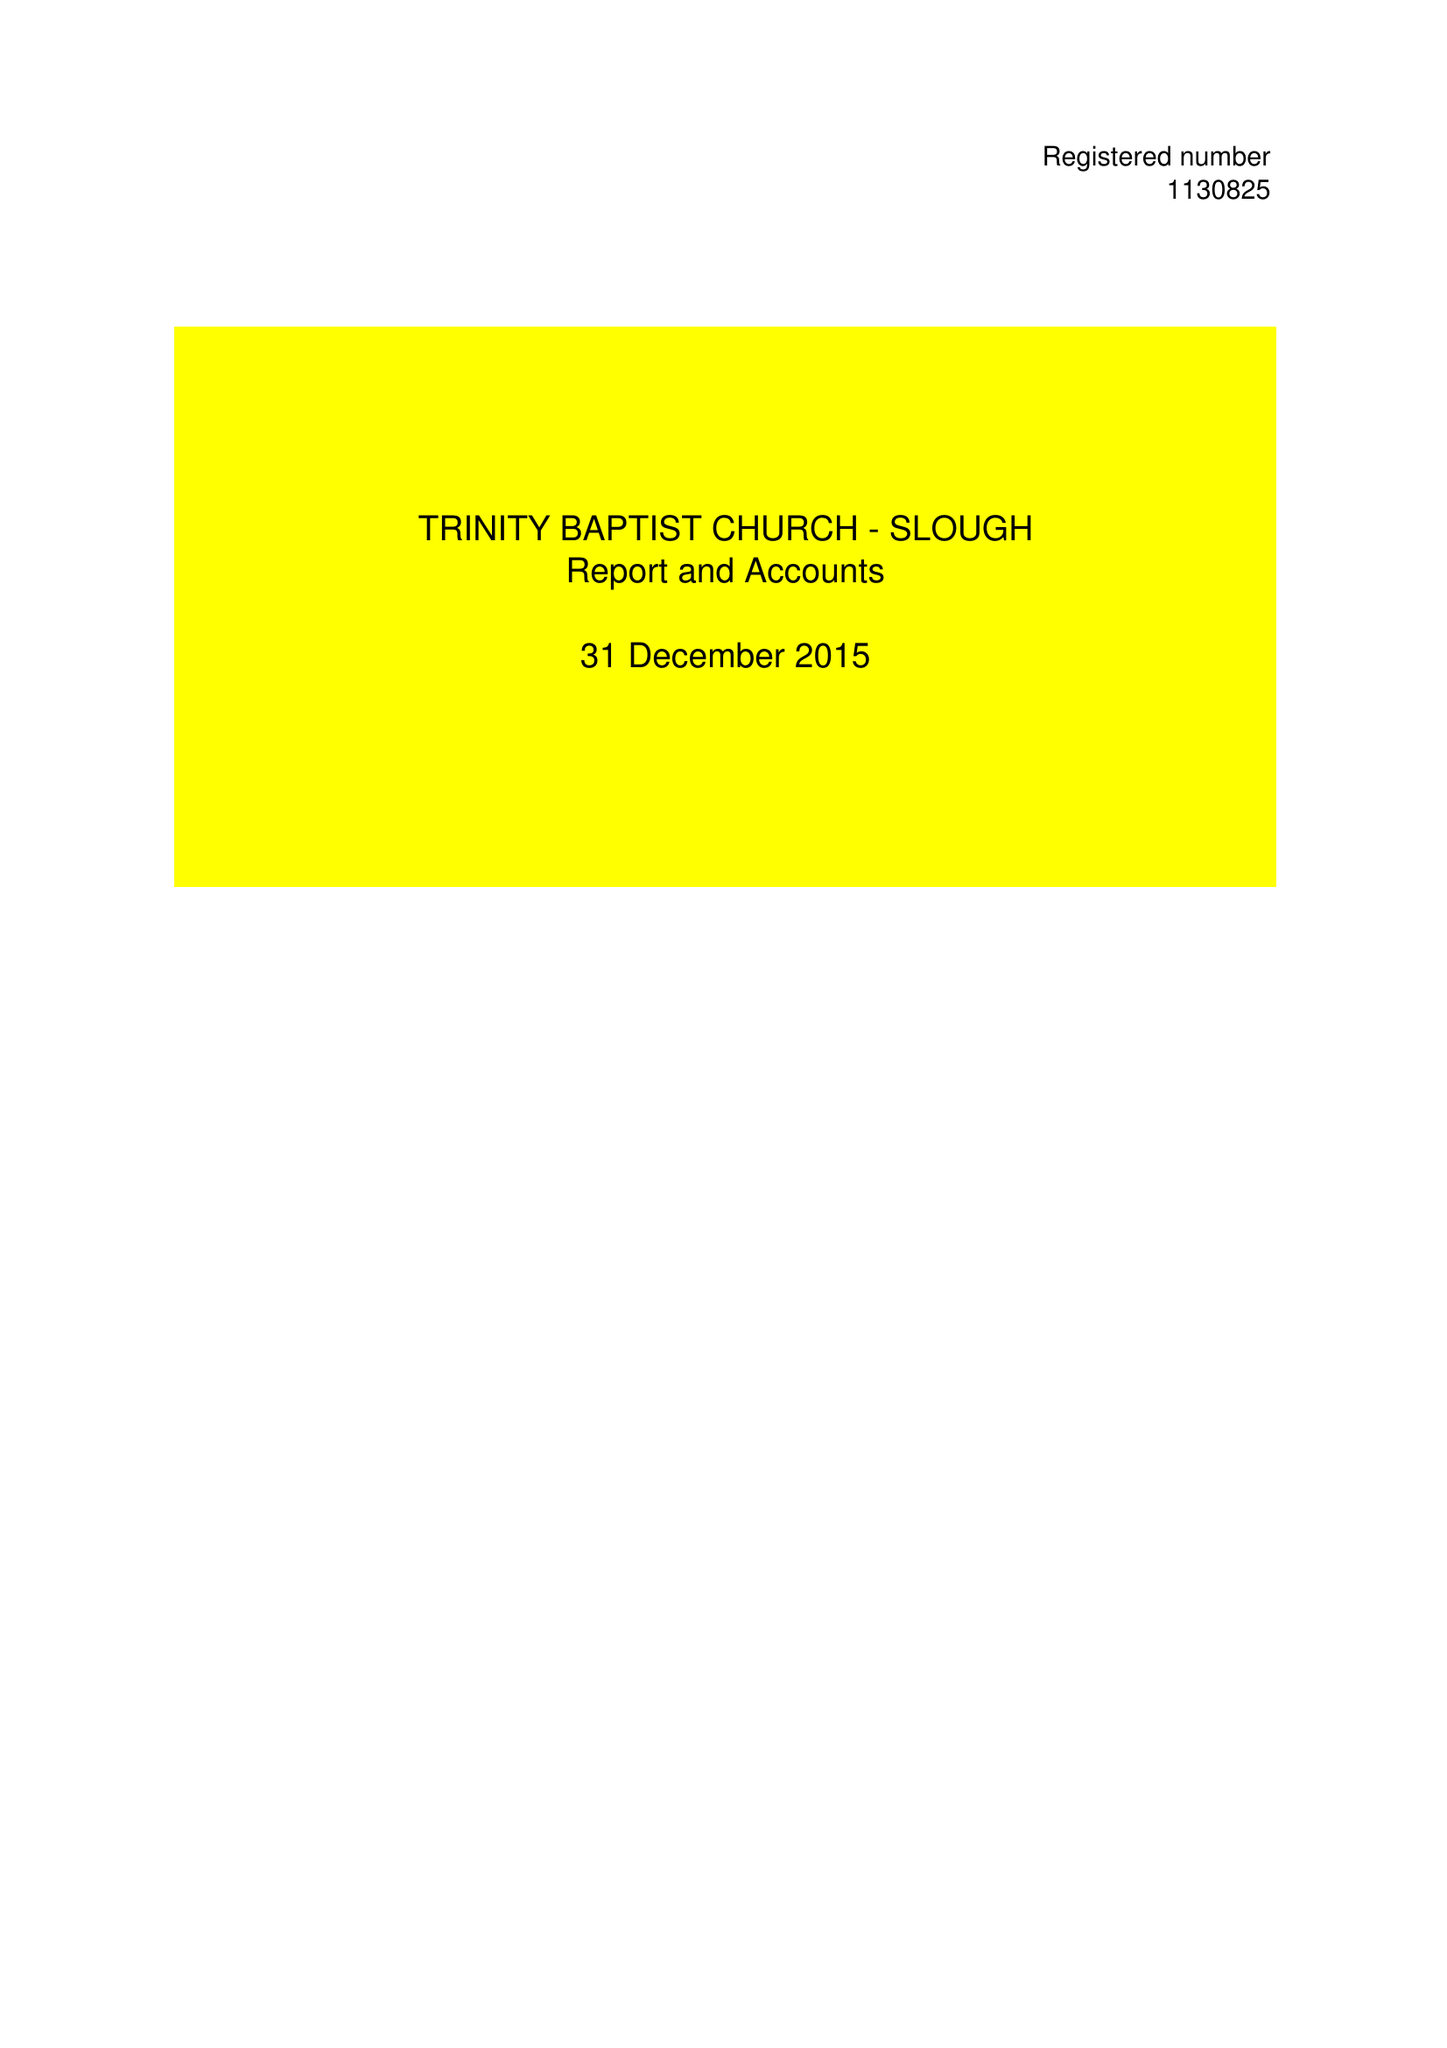What is the value for the address__street_line?
Answer the question using a single word or phrase. 76 GLAMORGAN CLOSE 